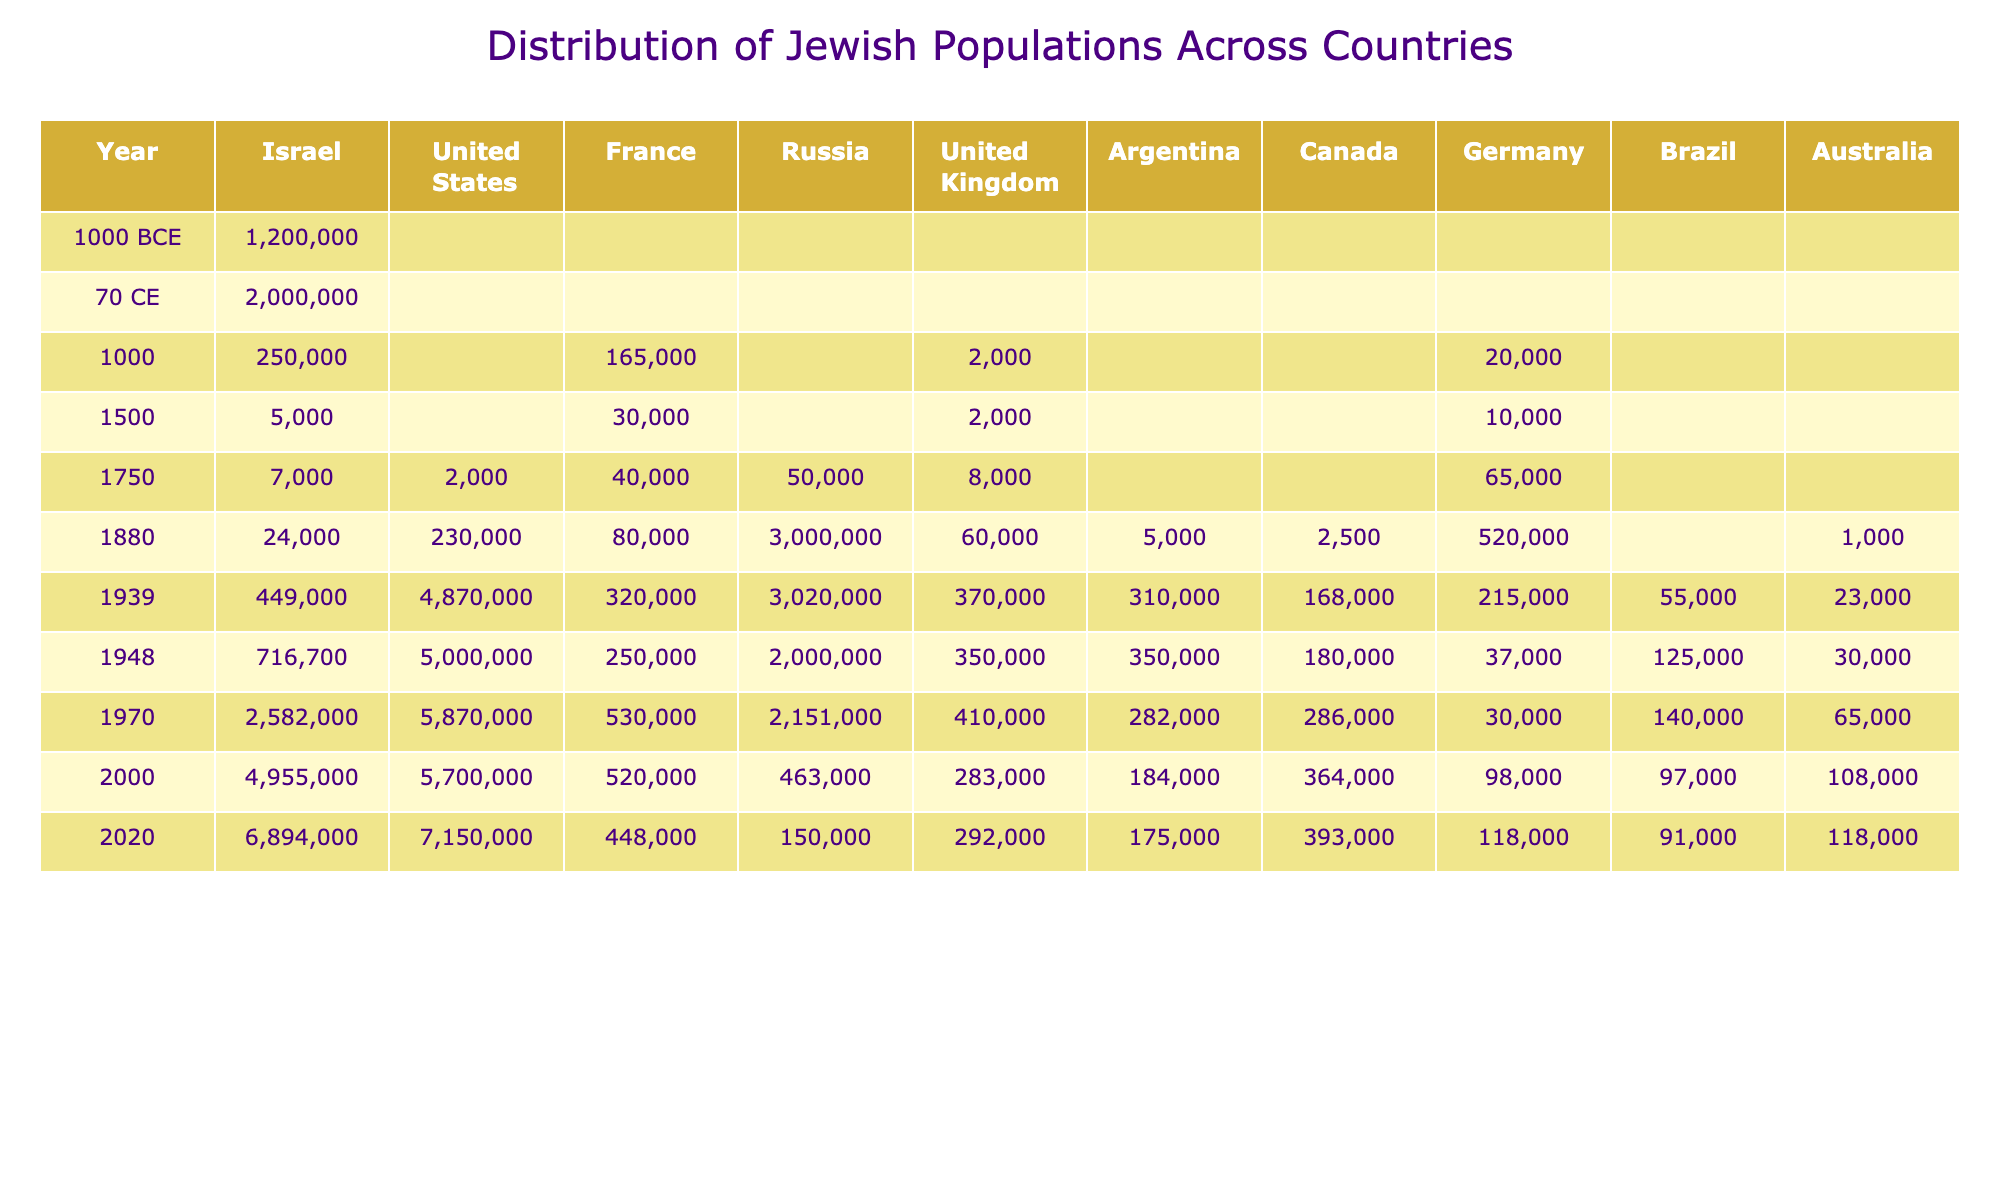What was the Jewish population in the United States in 1948? The table shows that the Jewish population in the United States in 1948 was 5,000,000.
Answer: 5,000,000 How many Jews were in France in 1939? According to the table, the Jewish population in France in 1939 was 320,000.
Answer: 320,000 What is the total Jewish population in 1800 for Israel, the United Kingdom, and Argentina combined? The populations for Israel, United Kingdom, and Argentina in 1800 are 7,000 (Israel) + 2,000 (United Kingdom) + 8,000 (Argentina) = 17,000.
Answer: 17,000 Was there a Jewish population in Brazil in 1750? The table indicates that the Jewish population in Brazil in 1750 was 0, meaning there was no Jewish population present at that time.
Answer: No Which year had the highest Jewish population in Germany? Looking at the data, 1880 shows 520,000 Jews in Germany, which is the highest number mentioned in the table for that country.
Answer: 1880 How much did the Jewish population in Russia decrease from 1880 to 1948? The population in Russia was 3,000,000 in 1880 and 2,000,000 in 1948, so the decrease is 3,000,000 - 2,000,000 = 1,000,000.
Answer: 1,000,000 What percentage of the total Jewish population in 2020 lived in the United States? In 2020, the U.S. had 7,150,000 Jews. The total population across all countries is 6,894,000 (Israel) + 7,150,000 (U.S.) + 448,000 (France) + 150,000 (Russia) + 292,000 (U.K.) + 175,000 (Argentina) + 393,000 (Canada) + 118,000 (Germany) + 91,000 (Brazil) + 118,000 (Australia) = 14,831,000. The percentage is (7,150,000 / 14,831,000) * 100 ≈ 48.1%.
Answer: Approximately 48.1% Which country had the lowest recorded Jewish population in the year 1000? The records show that the only population mentioned in the year 1000 was in Israel with 1,200,000; all other countries had 0 recorded populations, so they all share the lowest figure.
Answer: All had 0 or no population reported In which year did the Jewish population in Canada first appear in the table? In the table, the first recorded Jewish population in Canada appears in 1880 with 2,500 individuals.
Answer: 1880 What can be inferred about the trend of Jewish populations in Argentina from 1880 to 2020? The Jewish population in Argentina increased from 5,000 in 1880 to 175,000 in 2020, indicating growth over the years.
Answer: Growth over the years 